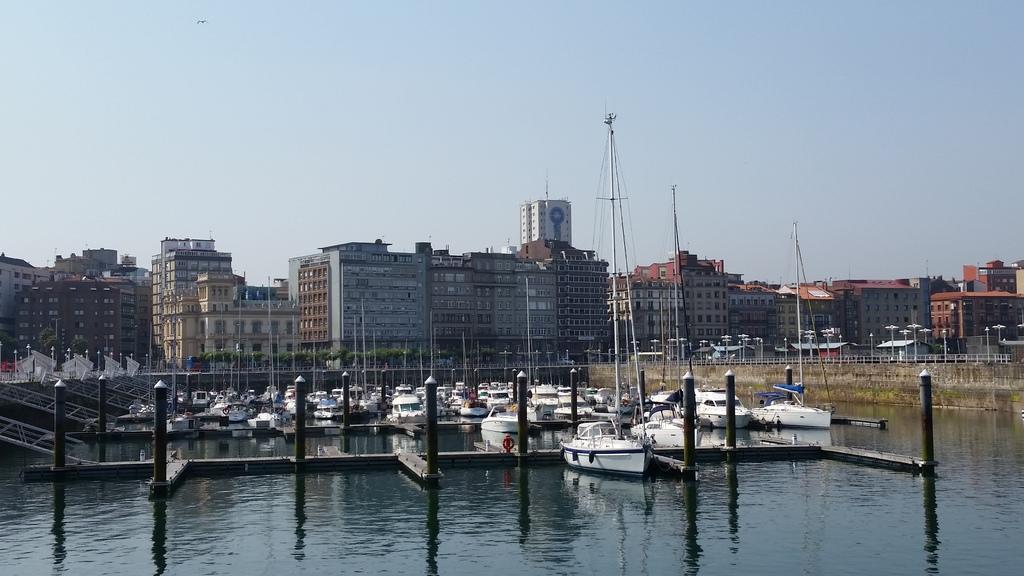Describe this image in one or two sentences. In this image we can see a few boats on the water, there are some buildings, poles, lights, fence and the wall, in the background we can see the sky. 